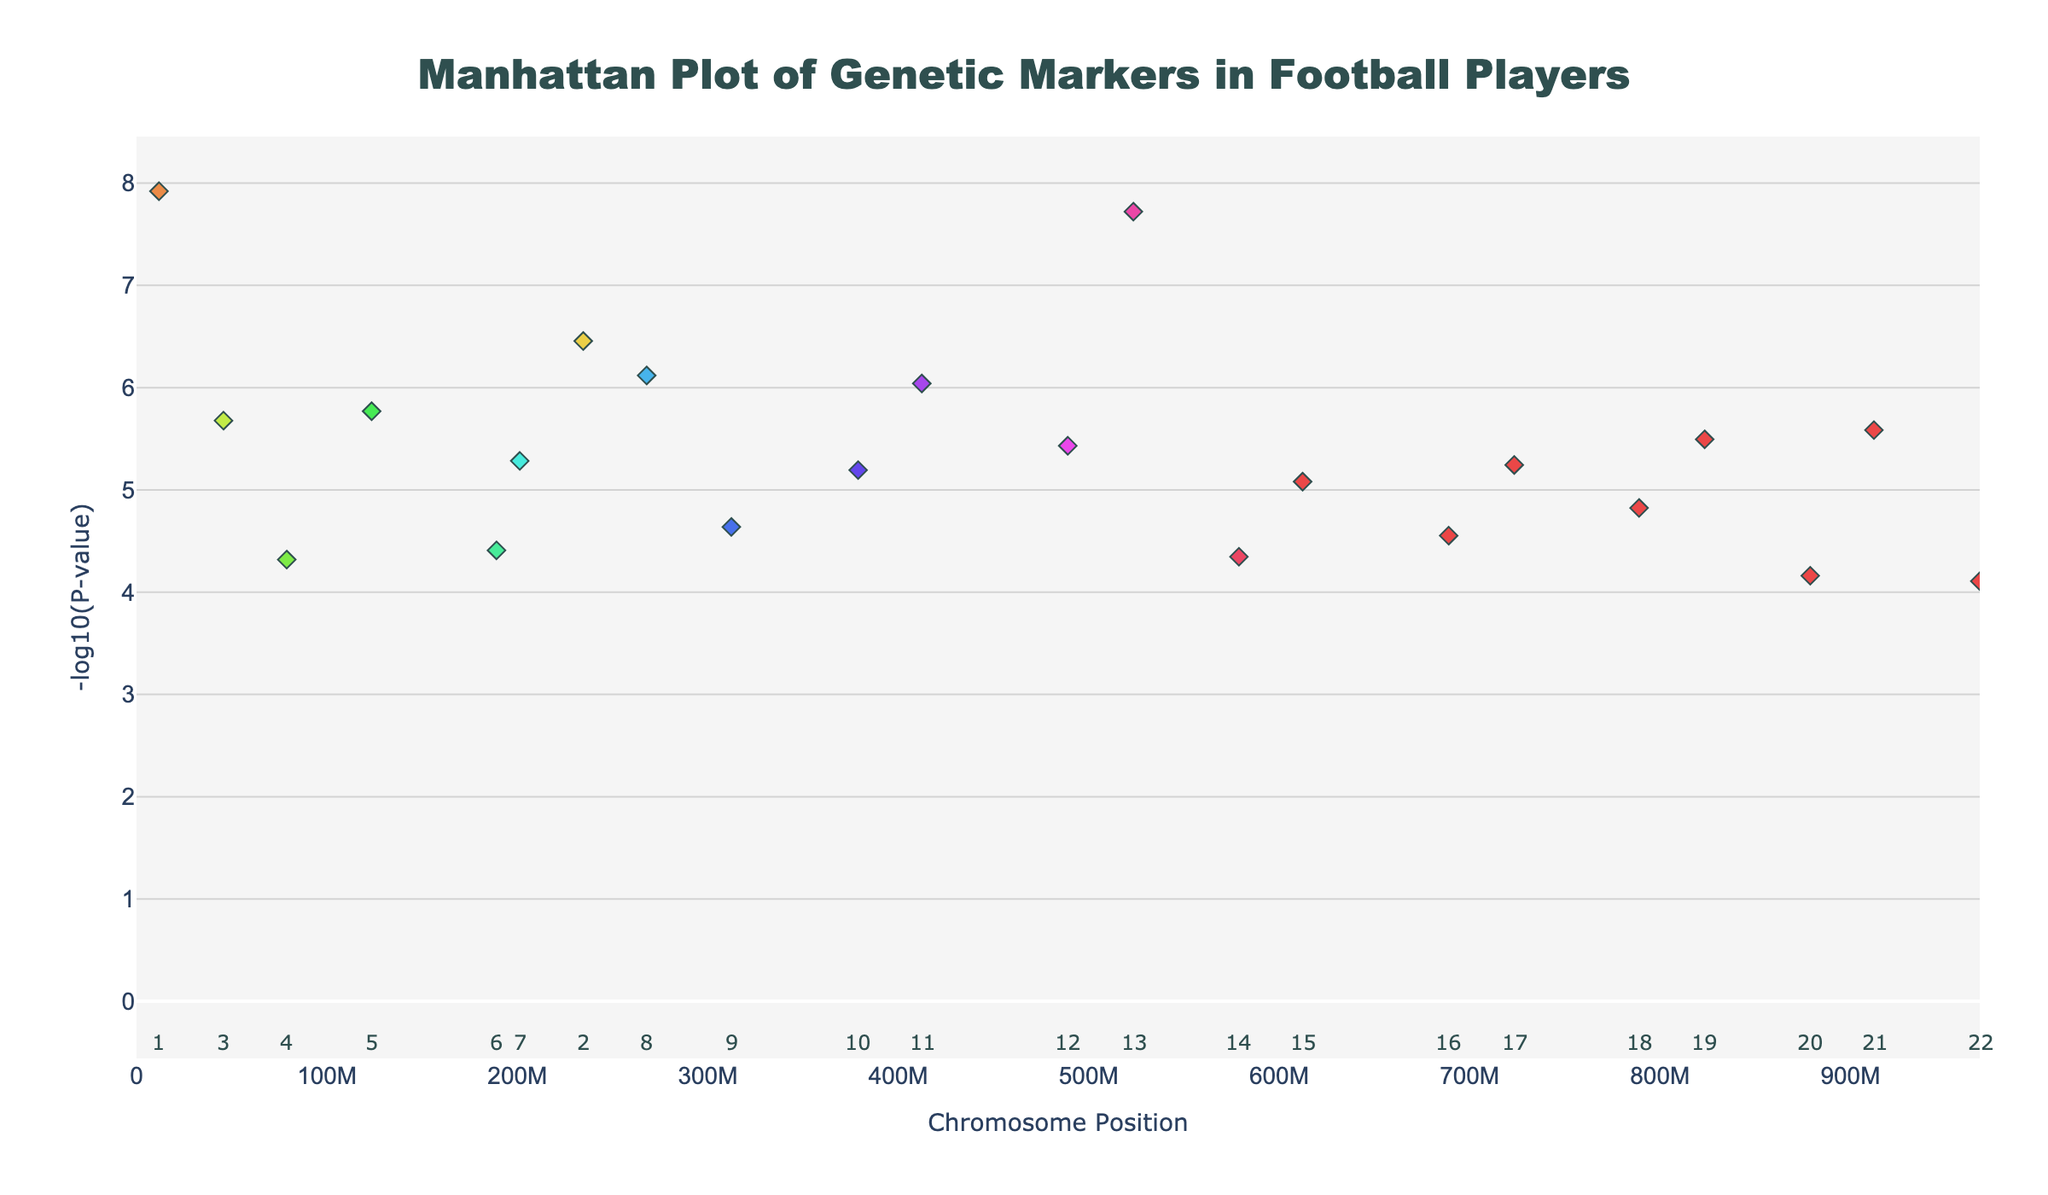What is the title of the plot? The title is displayed at the top center of the plot in a large font size, making it easily identifiable.
Answer: Manhattan Plot of Genetic Markers in Football Players Which chromosome has the genetic marker with the lowest P-value, and what is the associated gene? Chromosome 1 contains the genetic marker with the lowest P-value, which is visually identifiable as the data point with the highest -log10(P-value). The associated gene is ACTN3.
Answer: Chromosome 1, ACTN3 How many chromosomes are shown in the plot? Each chromosome is labeled with a number from 1 to 22, and the labels are visible below the x-axis of the plot.
Answer: 22 Which chromosome has the highest concentration of significant genetic markers based on the number of points? By visually inspecting the number of data points per chromosome, Chromosome 1 appears to have several points, indicating a high concentration of significant markers.
Answer: Chromosome 1 What trait is associated with the gene found at the highest position on Chromosome 8? By locating the highest point on Chromosome 8, we can see that the associated gene is VEGF, with the trait being angiogenesis, based on the hover information.
Answer: Angiogenesis What is the difference in -log10(P-value) between the highest markers on Chromosomes 2 and 3? First, identify the highest points on Chromosomes 2 and 3 and note their -log10(P-values). Subtract the smaller value from the larger one to find the difference. ‣ (log_p of Chromosome 2 = 6.46) and (log_p of Chromosome 3 = 5.68), so the difference is 6.46 - 5.68 = 0.78.
Answer: 0.78 Which genetic marker is associated with muscle growth, and what is the corresponding P-value? The gene associated with muscle growth is IGF1. The associated data point shows a P-value, which can be converted back from the -log10(P-value) shown in the plot. The P-value is 3.7e-6.
Answer: IGF1, 3.7e-6 Are any traits associated with genes on Chromosome 10? If so, what are they? By checking the hover information for points on Chromosome 10, we can identify the associated traits. Chromosome 10 has points associated with mitochondrial function, corresponding to the gene PPARGC1A.
Answer: Mitochondrial function What does the y-axis represent, and what range of values does it cover? The y-axis represents the -log10(P-value), which is a common transformation in Manhattan plots to better visualize small P-values. The range of values it covers starts from a small value close to zero up to the highest point determined by the data.
Answer: -log10(P-value), approximately from 0 to 8 Which chromosomes have genetic markers directly related to energy metabolism? By examining the hover information, Chromosome 16 (AMPD1) and Chromosome 21 (UCP2) have markers related to energy metabolism traits.
Answer: Chromosome 16 and Chromosome 21 